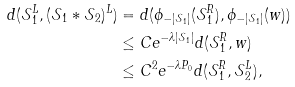Convert formula to latex. <formula><loc_0><loc_0><loc_500><loc_500>d ( \mathcal { S } _ { 1 } ^ { L } , ( \mathcal { S } _ { 1 } * \mathcal { S } _ { 2 } ) ^ { L } ) & = d ( \phi _ { - | \mathcal { S } _ { 1 } | } ( \mathcal { S } _ { 1 } ^ { R } ) , \phi _ { - | \mathcal { S } _ { 1 } | } ( w ) ) \\ & \leq C e ^ { - \lambda | \mathcal { S } _ { 1 } | } d ( \mathcal { S } _ { 1 } ^ { R } , w ) \\ & \leq C ^ { 2 } e ^ { - \lambda P _ { 0 } } d ( \mathcal { S } _ { 1 } ^ { R } , \mathcal { S } _ { 2 } ^ { L } ) ,</formula> 